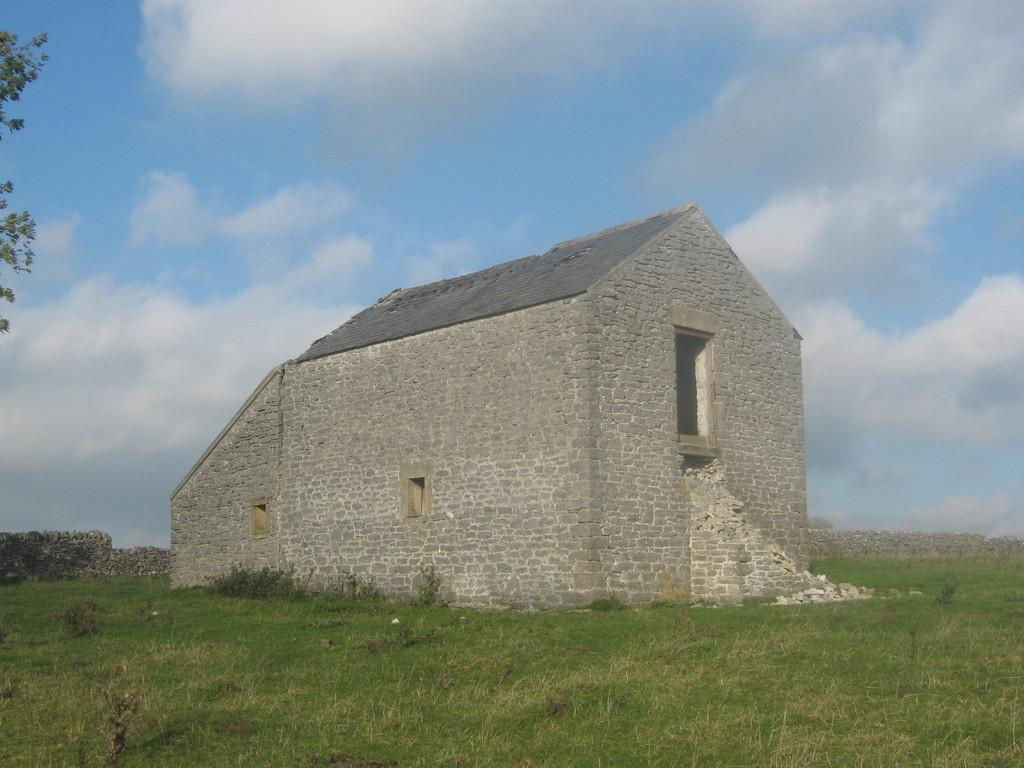Describe this image in one or two sentences. This picture shows a house and we see a blue cloudy sky and we see a tree on the side and grass on the ground. 